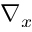Convert formula to latex. <formula><loc_0><loc_0><loc_500><loc_500>\nabla _ { x }</formula> 